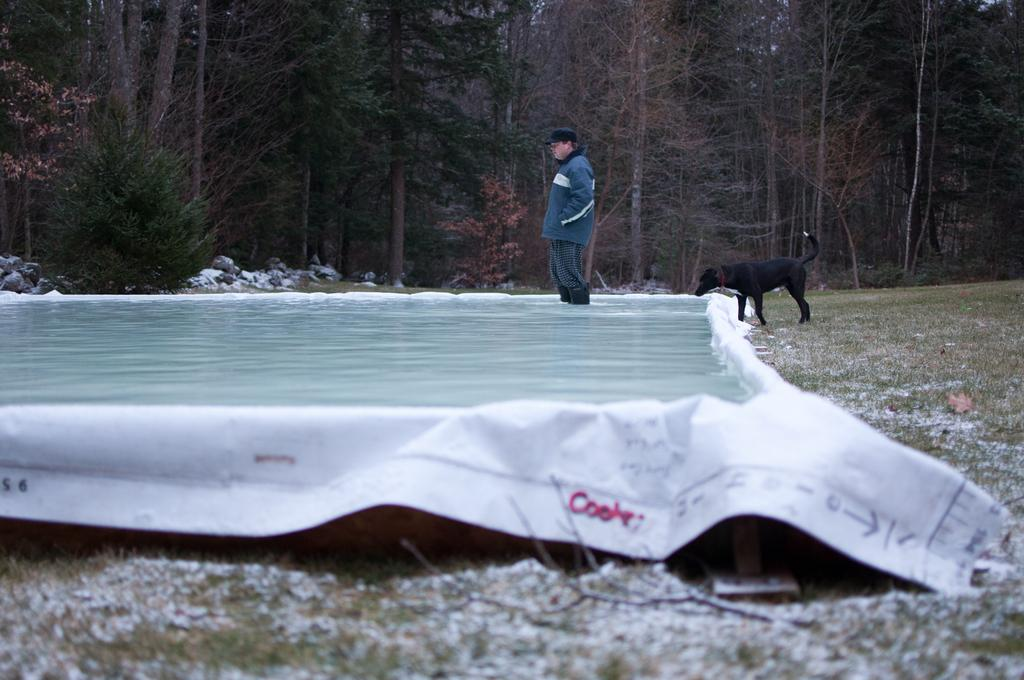What is the person in the image doing? The person is visible in the water, which suggests they might be swimming or playing in the water. What other living creature is present in the image? There is a dog visible in the image. What type of natural environment is visible in the image? Trees are visible at the top of the image, which suggests a natural setting. What object is visible at the bottom of the image? There is a cloth visible at the bottom of the image. What type of beam is holding up the history in the image? There is no beam or history present in the image; it features a person in the water and a dog. 